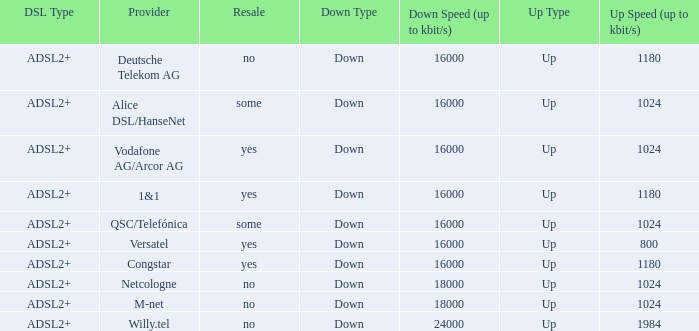Write the full table. {'header': ['DSL Type', 'Provider', 'Resale', 'Down Type', 'Down Speed (up to kbit/s)', 'Up Type', 'Up Speed (up to kbit/s)'], 'rows': [['ADSL2+', 'Deutsche Telekom AG', 'no', 'Down', '16000', 'Up', '1180'], ['ADSL2+', 'Alice DSL/HanseNet', 'some', 'Down', '16000', 'Up', '1024'], ['ADSL2+', 'Vodafone AG/Arcor AG', 'yes', 'Down', '16000', 'Up', '1024'], ['ADSL2+', '1&1', 'yes', 'Down', '16000', 'Up', '1180'], ['ADSL2+', 'QSC/Telefónica', 'some', 'Down', '16000', 'Up', '1024'], ['ADSL2+', 'Versatel', 'yes', 'Down', '16000', 'Up', '800'], ['ADSL2+', 'Congstar', 'yes', 'Down', '16000', 'Up', '1180'], ['ADSL2+', 'Netcologne', 'no', 'Down', '18000', 'Up', '1024'], ['ADSL2+', 'M-net', 'no', 'Down', '18000', 'Up', '1024'], ['ADSL2+', 'Willy.tel', 'no', 'Down', '24000', 'Up', '1984']]} How many providers are there where the resale category is yes and bandwith is up is 1024? 1.0. 